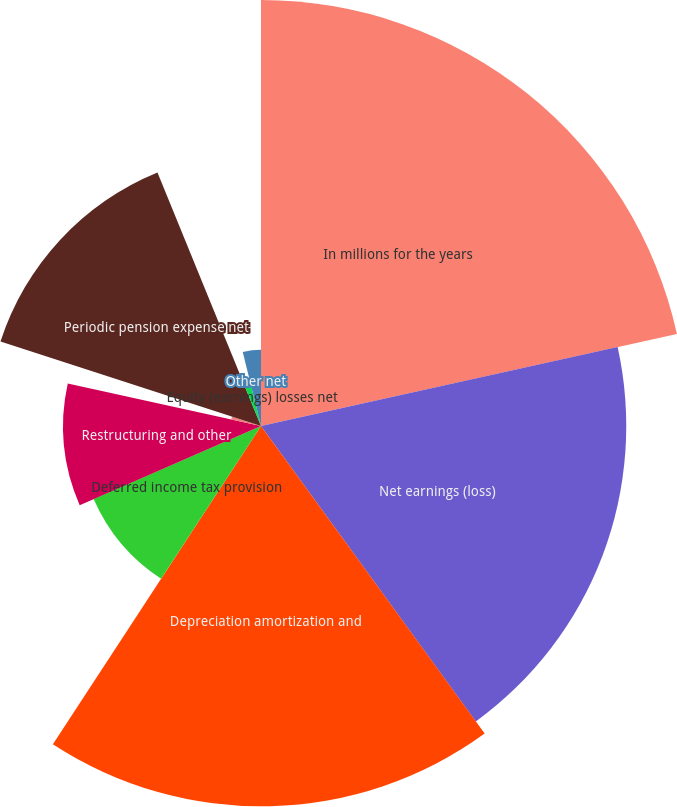<chart> <loc_0><loc_0><loc_500><loc_500><pie_chart><fcel>In millions for the years<fcel>Net earnings (loss)<fcel>Depreciation amortization and<fcel>Deferred income tax provision<fcel>Restructuring and other<fcel>Pension plan contribution<fcel>Periodic pension expense net<fcel>Net (gains) losses on sales<fcel>Equity (earnings) losses net<fcel>Other net<nl><fcel>21.53%<fcel>18.46%<fcel>19.22%<fcel>9.23%<fcel>10.0%<fcel>1.54%<fcel>13.84%<fcel>0.01%<fcel>2.31%<fcel>3.85%<nl></chart> 